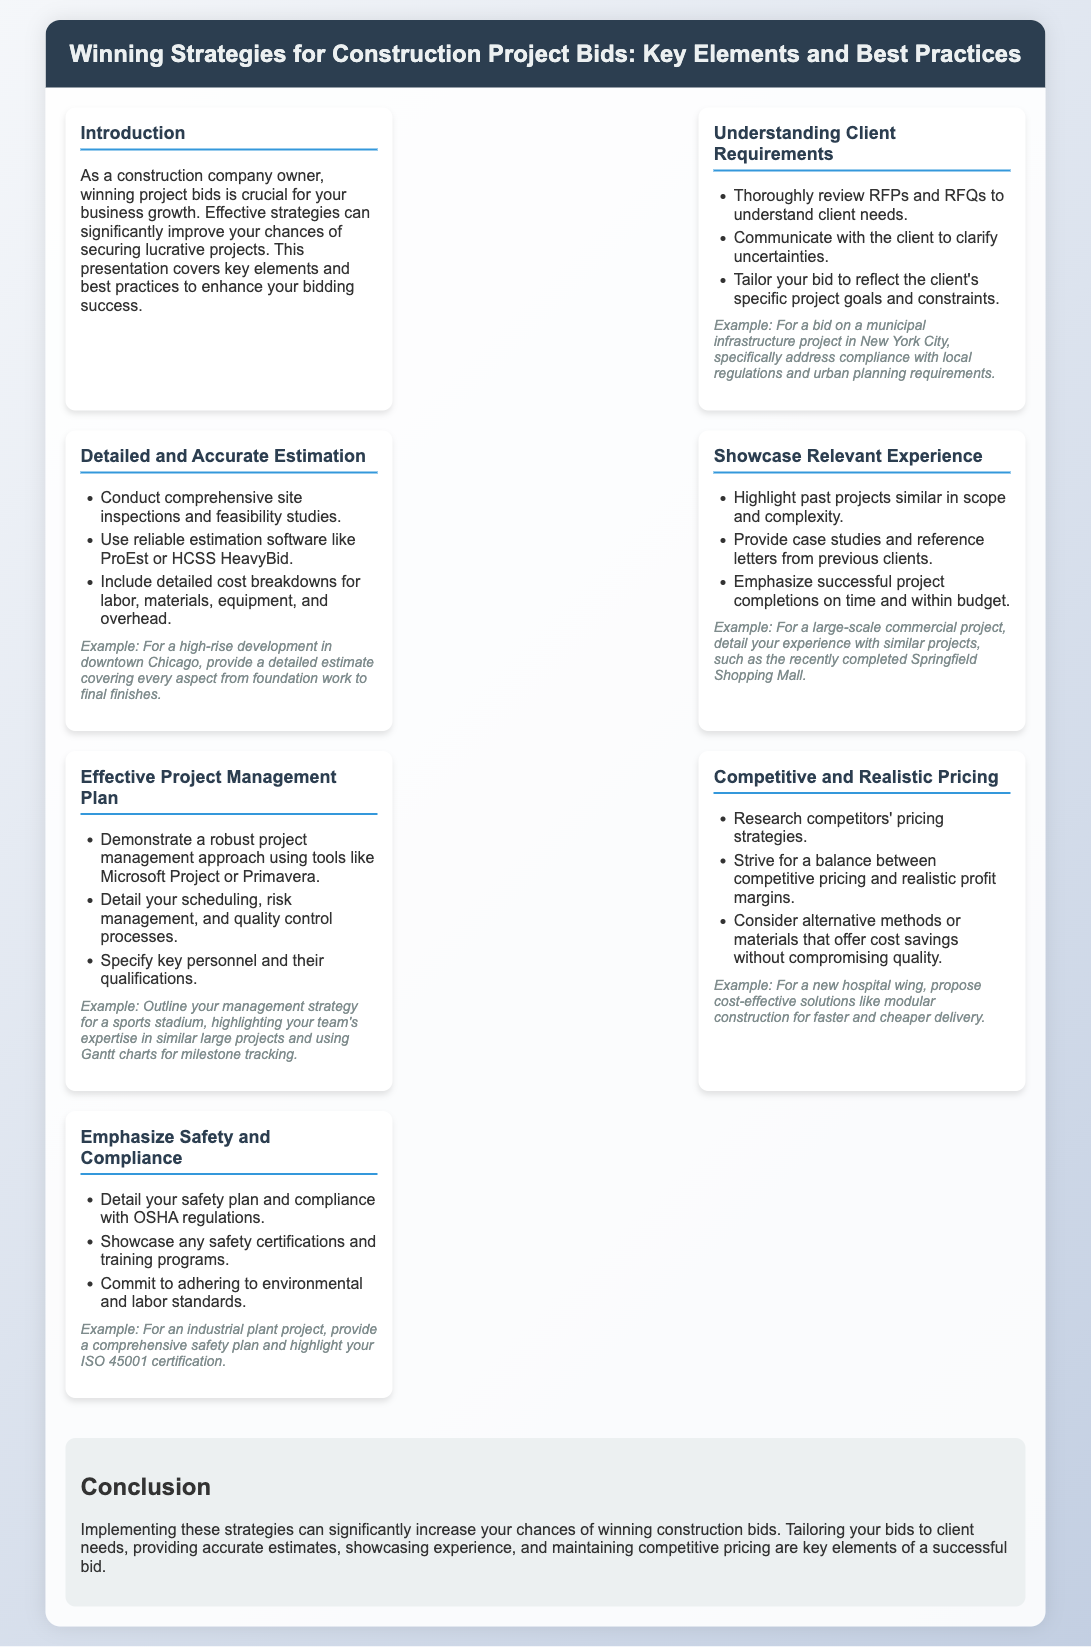What is the purpose of the presentation? The presentation covers strategies to improve chances of winning construction bids, emphasizing key elements and best practices.
Answer: Winning project bids What tool is suggested for project management? The document recommends using tools like Microsoft Project or Primavera for project management.
Answer: Microsoft Project What should you include in your cost breakdown? A detailed cost breakdown should include labor, materials, equipment, and overhead.
Answer: Labor, materials, equipment, and overhead What is emphasized alongside pricing strategies? The document emphasizes the importance of balancing competitive pricing with realistic profit margins.
Answer: Realistic profit margins Which certification is highlighted for safety? ISO 45001 certification is mentioned as an important safety certification.
Answer: ISO 45001 What example is given for a municipal project? The example provided addresses compliance with local regulations and urban planning requirements for a municipal infrastructure project in New York City.
Answer: Compliance with local regulations What is a common method suggested to improve safety? Providing a comprehensive safety plan is a suggested method to improve safety in project bids.
Answer: Comprehensive safety plan How can you showcase relevant experience? Past projects similar in scope and complexity should be highlighted to showcase relevant experience.
Answer: Past projects What type of plan should be demonstrated to enhance bids? A robust project management plan should be demonstrated to enhance bids.
Answer: Robust project management plan 